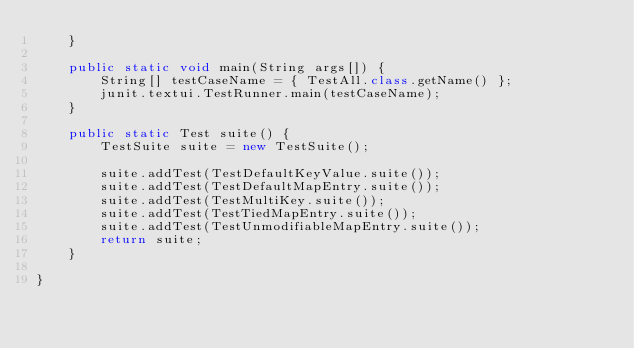Convert code to text. <code><loc_0><loc_0><loc_500><loc_500><_Java_>    }

    public static void main(String args[]) {
        String[] testCaseName = { TestAll.class.getName() };
        junit.textui.TestRunner.main(testCaseName);
    }
    
    public static Test suite() {
        TestSuite suite = new TestSuite();
        
        suite.addTest(TestDefaultKeyValue.suite());
        suite.addTest(TestDefaultMapEntry.suite());
        suite.addTest(TestMultiKey.suite());
        suite.addTest(TestTiedMapEntry.suite());
        suite.addTest(TestUnmodifiableMapEntry.suite());
        return suite;
    }
        
}
</code> 